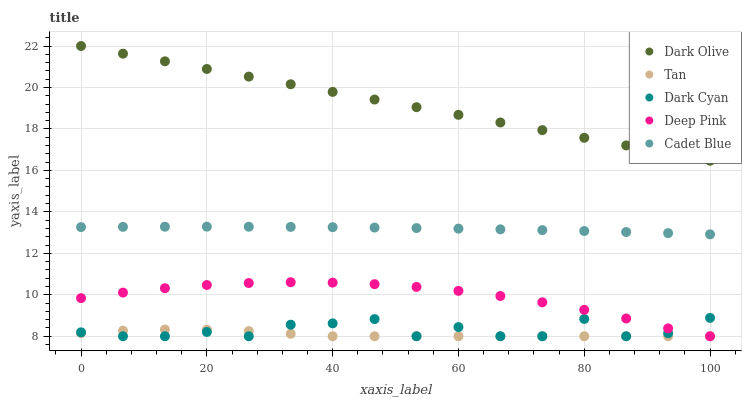Does Tan have the minimum area under the curve?
Answer yes or no. Yes. Does Dark Olive have the maximum area under the curve?
Answer yes or no. Yes. Does Dark Olive have the minimum area under the curve?
Answer yes or no. No. Does Tan have the maximum area under the curve?
Answer yes or no. No. Is Dark Olive the smoothest?
Answer yes or no. Yes. Is Dark Cyan the roughest?
Answer yes or no. Yes. Is Tan the smoothest?
Answer yes or no. No. Is Tan the roughest?
Answer yes or no. No. Does Dark Cyan have the lowest value?
Answer yes or no. Yes. Does Dark Olive have the lowest value?
Answer yes or no. No. Does Dark Olive have the highest value?
Answer yes or no. Yes. Does Tan have the highest value?
Answer yes or no. No. Is Dark Cyan less than Dark Olive?
Answer yes or no. Yes. Is Dark Olive greater than Tan?
Answer yes or no. Yes. Does Dark Cyan intersect Deep Pink?
Answer yes or no. Yes. Is Dark Cyan less than Deep Pink?
Answer yes or no. No. Is Dark Cyan greater than Deep Pink?
Answer yes or no. No. Does Dark Cyan intersect Dark Olive?
Answer yes or no. No. 